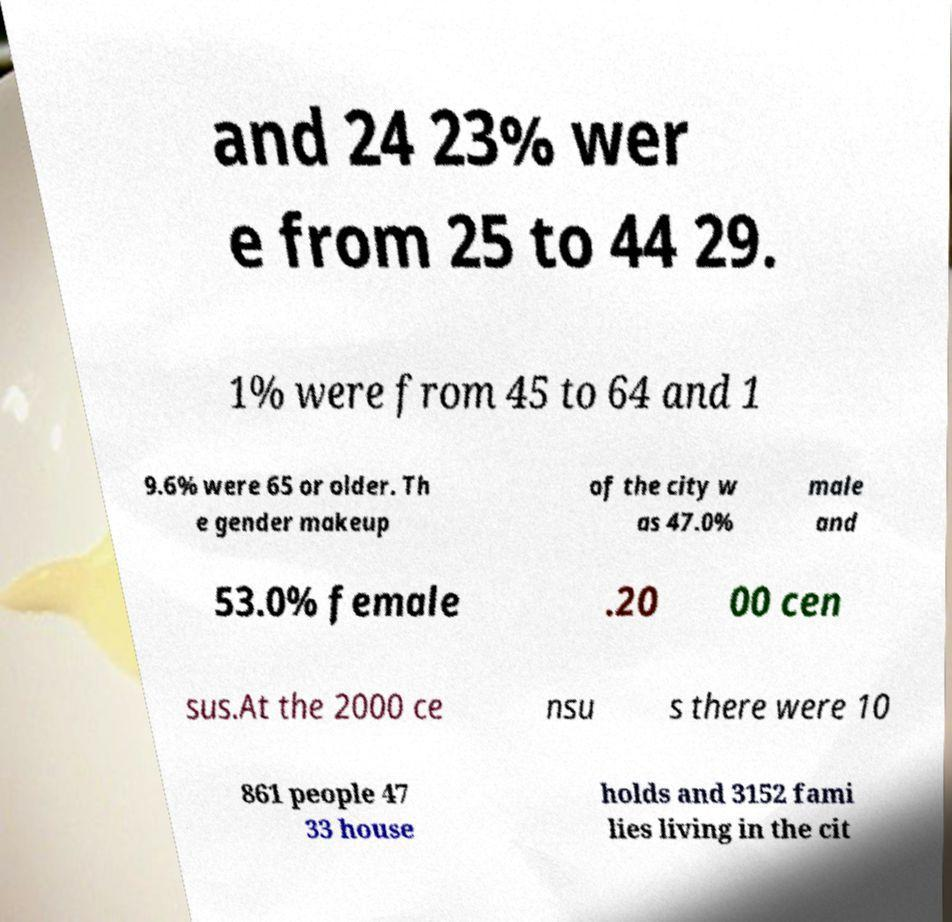For documentation purposes, I need the text within this image transcribed. Could you provide that? and 24 23% wer e from 25 to 44 29. 1% were from 45 to 64 and 1 9.6% were 65 or older. Th e gender makeup of the city w as 47.0% male and 53.0% female .20 00 cen sus.At the 2000 ce nsu s there were 10 861 people 47 33 house holds and 3152 fami lies living in the cit 